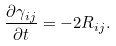<formula> <loc_0><loc_0><loc_500><loc_500>\frac { \partial \gamma _ { i j } } { \partial t } = - 2 R _ { i j } .</formula> 